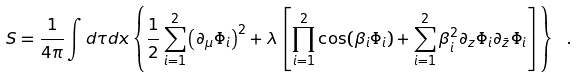<formula> <loc_0><loc_0><loc_500><loc_500>S = \frac { 1 } { 4 \pi } \int d \tau d x \left \{ \frac { 1 } { 2 } \sum _ { i = 1 } ^ { 2 } { \left ( \partial _ { \mu } \Phi _ { i } \right ) } ^ { 2 } + \lambda \left [ \prod _ { i = 1 } ^ { 2 } \cos ( { \beta } _ { i } \Phi _ { i } ) + \sum _ { i = 1 } ^ { 2 } \beta _ { i } ^ { 2 } \partial _ { z } \Phi _ { i } \partial _ { \bar { z } } \Phi _ { i } \right ] \right \} \ .</formula> 